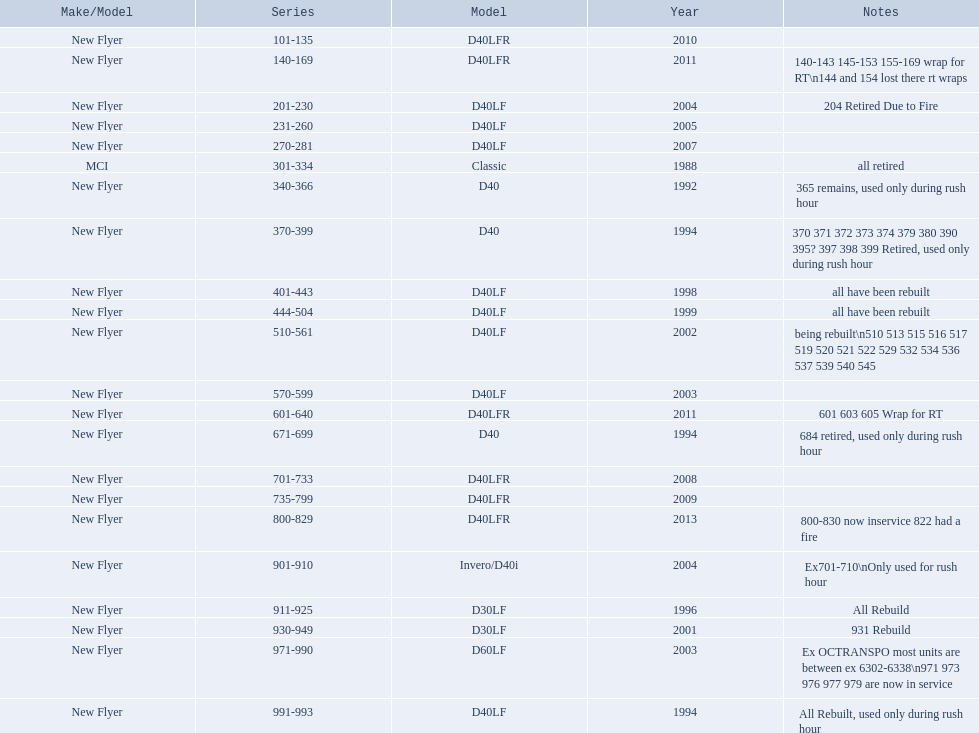What are all the models of buses? D40LFR, D40LF, Classic, D40, Invero/D40i, D30LF, D60LF. Of these buses, which series is the oldest? 301-334. Which is the  newest? 800-829. 